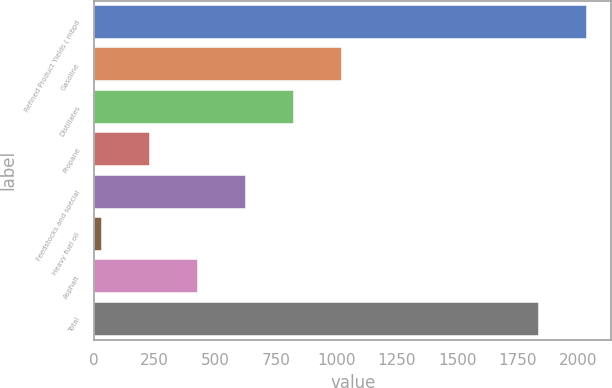Convert chart to OTSL. <chart><loc_0><loc_0><loc_500><loc_500><bar_chart><fcel>Refined Product Yields ( mbpd<fcel>Gasoline<fcel>Distillates<fcel>Propane<fcel>Feedstocks and special<fcel>Heavy fuel oil<fcel>Asphalt<fcel>Total<nl><fcel>2034.2<fcel>1022<fcel>823.8<fcel>229.2<fcel>625.6<fcel>31<fcel>427.4<fcel>1836<nl></chart> 